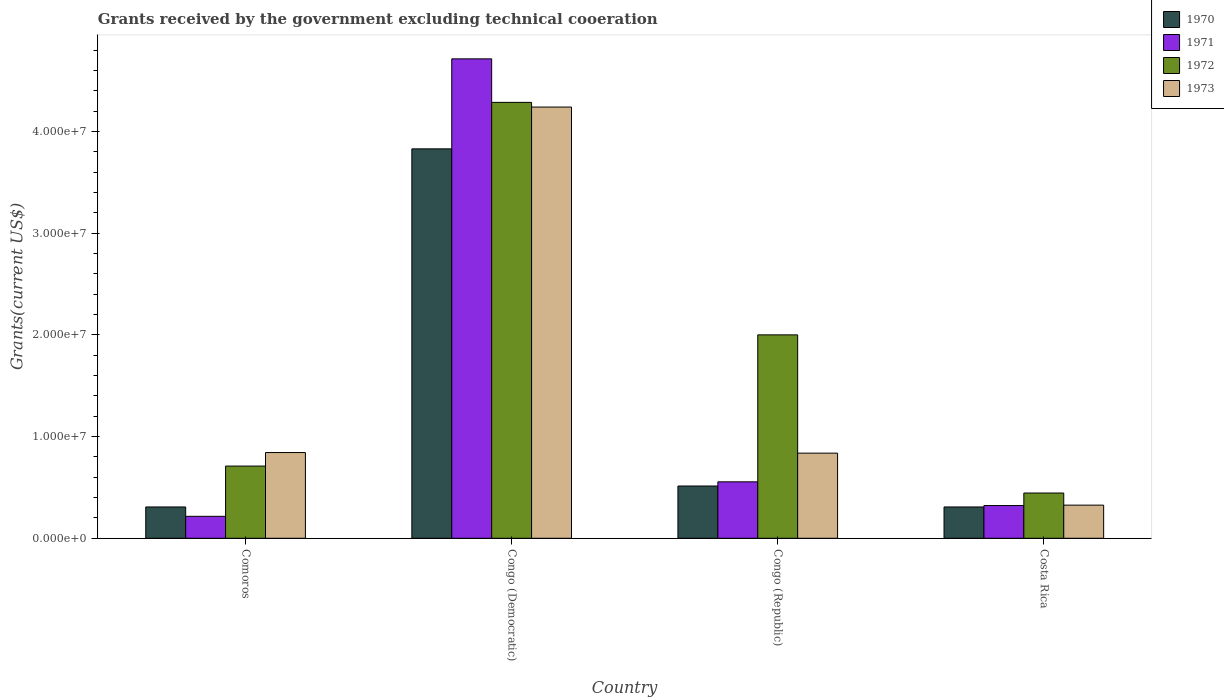Are the number of bars on each tick of the X-axis equal?
Offer a very short reply. Yes. What is the label of the 3rd group of bars from the left?
Provide a succinct answer. Congo (Republic). What is the total grants received by the government in 1973 in Congo (Democratic)?
Your answer should be very brief. 4.24e+07. Across all countries, what is the maximum total grants received by the government in 1971?
Your answer should be compact. 4.71e+07. Across all countries, what is the minimum total grants received by the government in 1973?
Offer a very short reply. 3.26e+06. In which country was the total grants received by the government in 1973 maximum?
Ensure brevity in your answer.  Congo (Democratic). What is the total total grants received by the government in 1972 in the graph?
Give a very brief answer. 7.44e+07. What is the difference between the total grants received by the government in 1972 in Comoros and that in Costa Rica?
Offer a terse response. 2.65e+06. What is the difference between the total grants received by the government in 1971 in Congo (Democratic) and the total grants received by the government in 1970 in Congo (Republic)?
Your answer should be very brief. 4.20e+07. What is the average total grants received by the government in 1970 per country?
Ensure brevity in your answer.  1.24e+07. What is the difference between the total grants received by the government of/in 1972 and total grants received by the government of/in 1970 in Congo (Democratic)?
Your answer should be very brief. 4.57e+06. In how many countries, is the total grants received by the government in 1971 greater than 16000000 US$?
Offer a terse response. 1. What is the ratio of the total grants received by the government in 1972 in Congo (Democratic) to that in Costa Rica?
Provide a short and direct response. 9.63. Is the difference between the total grants received by the government in 1972 in Comoros and Congo (Democratic) greater than the difference between the total grants received by the government in 1970 in Comoros and Congo (Democratic)?
Your response must be concise. No. What is the difference between the highest and the second highest total grants received by the government in 1970?
Give a very brief answer. 3.32e+07. What is the difference between the highest and the lowest total grants received by the government in 1973?
Keep it short and to the point. 3.91e+07. Is the sum of the total grants received by the government in 1970 in Comoros and Congo (Republic) greater than the maximum total grants received by the government in 1972 across all countries?
Make the answer very short. No. Is it the case that in every country, the sum of the total grants received by the government in 1973 and total grants received by the government in 1970 is greater than the sum of total grants received by the government in 1972 and total grants received by the government in 1971?
Offer a terse response. No. Is it the case that in every country, the sum of the total grants received by the government in 1971 and total grants received by the government in 1973 is greater than the total grants received by the government in 1972?
Ensure brevity in your answer.  No. How many bars are there?
Your answer should be very brief. 16. How many countries are there in the graph?
Make the answer very short. 4. Are the values on the major ticks of Y-axis written in scientific E-notation?
Keep it short and to the point. Yes. Does the graph contain any zero values?
Give a very brief answer. No. How many legend labels are there?
Offer a terse response. 4. What is the title of the graph?
Keep it short and to the point. Grants received by the government excluding technical cooeration. Does "1970" appear as one of the legend labels in the graph?
Your answer should be very brief. Yes. What is the label or title of the X-axis?
Ensure brevity in your answer.  Country. What is the label or title of the Y-axis?
Ensure brevity in your answer.  Grants(current US$). What is the Grants(current US$) of 1970 in Comoros?
Offer a terse response. 3.08e+06. What is the Grants(current US$) in 1971 in Comoros?
Your answer should be very brief. 2.16e+06. What is the Grants(current US$) in 1972 in Comoros?
Your answer should be very brief. 7.10e+06. What is the Grants(current US$) of 1973 in Comoros?
Make the answer very short. 8.43e+06. What is the Grants(current US$) of 1970 in Congo (Democratic)?
Provide a succinct answer. 3.83e+07. What is the Grants(current US$) in 1971 in Congo (Democratic)?
Provide a short and direct response. 4.71e+07. What is the Grants(current US$) of 1972 in Congo (Democratic)?
Ensure brevity in your answer.  4.29e+07. What is the Grants(current US$) of 1973 in Congo (Democratic)?
Give a very brief answer. 4.24e+07. What is the Grants(current US$) in 1970 in Congo (Republic)?
Your answer should be very brief. 5.14e+06. What is the Grants(current US$) of 1971 in Congo (Republic)?
Provide a short and direct response. 5.55e+06. What is the Grants(current US$) in 1972 in Congo (Republic)?
Provide a short and direct response. 2.00e+07. What is the Grants(current US$) in 1973 in Congo (Republic)?
Ensure brevity in your answer.  8.37e+06. What is the Grants(current US$) of 1970 in Costa Rica?
Make the answer very short. 3.08e+06. What is the Grants(current US$) in 1971 in Costa Rica?
Offer a terse response. 3.22e+06. What is the Grants(current US$) of 1972 in Costa Rica?
Your response must be concise. 4.45e+06. What is the Grants(current US$) of 1973 in Costa Rica?
Provide a succinct answer. 3.26e+06. Across all countries, what is the maximum Grants(current US$) of 1970?
Provide a succinct answer. 3.83e+07. Across all countries, what is the maximum Grants(current US$) of 1971?
Keep it short and to the point. 4.71e+07. Across all countries, what is the maximum Grants(current US$) in 1972?
Your answer should be compact. 4.29e+07. Across all countries, what is the maximum Grants(current US$) of 1973?
Make the answer very short. 4.24e+07. Across all countries, what is the minimum Grants(current US$) in 1970?
Your answer should be very brief. 3.08e+06. Across all countries, what is the minimum Grants(current US$) in 1971?
Keep it short and to the point. 2.16e+06. Across all countries, what is the minimum Grants(current US$) in 1972?
Your answer should be very brief. 4.45e+06. Across all countries, what is the minimum Grants(current US$) of 1973?
Provide a succinct answer. 3.26e+06. What is the total Grants(current US$) of 1970 in the graph?
Keep it short and to the point. 4.96e+07. What is the total Grants(current US$) of 1971 in the graph?
Keep it short and to the point. 5.81e+07. What is the total Grants(current US$) of 1972 in the graph?
Offer a very short reply. 7.44e+07. What is the total Grants(current US$) in 1973 in the graph?
Provide a succinct answer. 6.25e+07. What is the difference between the Grants(current US$) in 1970 in Comoros and that in Congo (Democratic)?
Make the answer very short. -3.52e+07. What is the difference between the Grants(current US$) in 1971 in Comoros and that in Congo (Democratic)?
Your answer should be very brief. -4.50e+07. What is the difference between the Grants(current US$) of 1972 in Comoros and that in Congo (Democratic)?
Your answer should be very brief. -3.58e+07. What is the difference between the Grants(current US$) of 1973 in Comoros and that in Congo (Democratic)?
Your answer should be very brief. -3.40e+07. What is the difference between the Grants(current US$) in 1970 in Comoros and that in Congo (Republic)?
Provide a short and direct response. -2.06e+06. What is the difference between the Grants(current US$) of 1971 in Comoros and that in Congo (Republic)?
Offer a terse response. -3.39e+06. What is the difference between the Grants(current US$) in 1972 in Comoros and that in Congo (Republic)?
Offer a terse response. -1.29e+07. What is the difference between the Grants(current US$) in 1970 in Comoros and that in Costa Rica?
Ensure brevity in your answer.  0. What is the difference between the Grants(current US$) of 1971 in Comoros and that in Costa Rica?
Provide a short and direct response. -1.06e+06. What is the difference between the Grants(current US$) of 1972 in Comoros and that in Costa Rica?
Offer a terse response. 2.65e+06. What is the difference between the Grants(current US$) in 1973 in Comoros and that in Costa Rica?
Make the answer very short. 5.17e+06. What is the difference between the Grants(current US$) of 1970 in Congo (Democratic) and that in Congo (Republic)?
Provide a short and direct response. 3.32e+07. What is the difference between the Grants(current US$) of 1971 in Congo (Democratic) and that in Congo (Republic)?
Your answer should be compact. 4.16e+07. What is the difference between the Grants(current US$) of 1972 in Congo (Democratic) and that in Congo (Republic)?
Your answer should be very brief. 2.29e+07. What is the difference between the Grants(current US$) of 1973 in Congo (Democratic) and that in Congo (Republic)?
Provide a succinct answer. 3.40e+07. What is the difference between the Grants(current US$) of 1970 in Congo (Democratic) and that in Costa Rica?
Offer a terse response. 3.52e+07. What is the difference between the Grants(current US$) in 1971 in Congo (Democratic) and that in Costa Rica?
Provide a succinct answer. 4.39e+07. What is the difference between the Grants(current US$) in 1972 in Congo (Democratic) and that in Costa Rica?
Your answer should be compact. 3.84e+07. What is the difference between the Grants(current US$) in 1973 in Congo (Democratic) and that in Costa Rica?
Your answer should be very brief. 3.91e+07. What is the difference between the Grants(current US$) of 1970 in Congo (Republic) and that in Costa Rica?
Provide a succinct answer. 2.06e+06. What is the difference between the Grants(current US$) in 1971 in Congo (Republic) and that in Costa Rica?
Offer a terse response. 2.33e+06. What is the difference between the Grants(current US$) in 1972 in Congo (Republic) and that in Costa Rica?
Your response must be concise. 1.56e+07. What is the difference between the Grants(current US$) of 1973 in Congo (Republic) and that in Costa Rica?
Your answer should be very brief. 5.11e+06. What is the difference between the Grants(current US$) in 1970 in Comoros and the Grants(current US$) in 1971 in Congo (Democratic)?
Your response must be concise. -4.41e+07. What is the difference between the Grants(current US$) in 1970 in Comoros and the Grants(current US$) in 1972 in Congo (Democratic)?
Your answer should be very brief. -3.98e+07. What is the difference between the Grants(current US$) in 1970 in Comoros and the Grants(current US$) in 1973 in Congo (Democratic)?
Give a very brief answer. -3.93e+07. What is the difference between the Grants(current US$) of 1971 in Comoros and the Grants(current US$) of 1972 in Congo (Democratic)?
Offer a very short reply. -4.07e+07. What is the difference between the Grants(current US$) of 1971 in Comoros and the Grants(current US$) of 1973 in Congo (Democratic)?
Offer a terse response. -4.02e+07. What is the difference between the Grants(current US$) in 1972 in Comoros and the Grants(current US$) in 1973 in Congo (Democratic)?
Keep it short and to the point. -3.53e+07. What is the difference between the Grants(current US$) of 1970 in Comoros and the Grants(current US$) of 1971 in Congo (Republic)?
Your response must be concise. -2.47e+06. What is the difference between the Grants(current US$) of 1970 in Comoros and the Grants(current US$) of 1972 in Congo (Republic)?
Provide a short and direct response. -1.69e+07. What is the difference between the Grants(current US$) in 1970 in Comoros and the Grants(current US$) in 1973 in Congo (Republic)?
Give a very brief answer. -5.29e+06. What is the difference between the Grants(current US$) of 1971 in Comoros and the Grants(current US$) of 1972 in Congo (Republic)?
Give a very brief answer. -1.78e+07. What is the difference between the Grants(current US$) of 1971 in Comoros and the Grants(current US$) of 1973 in Congo (Republic)?
Make the answer very short. -6.21e+06. What is the difference between the Grants(current US$) in 1972 in Comoros and the Grants(current US$) in 1973 in Congo (Republic)?
Your response must be concise. -1.27e+06. What is the difference between the Grants(current US$) of 1970 in Comoros and the Grants(current US$) of 1972 in Costa Rica?
Offer a terse response. -1.37e+06. What is the difference between the Grants(current US$) of 1970 in Comoros and the Grants(current US$) of 1973 in Costa Rica?
Your answer should be very brief. -1.80e+05. What is the difference between the Grants(current US$) in 1971 in Comoros and the Grants(current US$) in 1972 in Costa Rica?
Your answer should be very brief. -2.29e+06. What is the difference between the Grants(current US$) of 1971 in Comoros and the Grants(current US$) of 1973 in Costa Rica?
Offer a very short reply. -1.10e+06. What is the difference between the Grants(current US$) in 1972 in Comoros and the Grants(current US$) in 1973 in Costa Rica?
Make the answer very short. 3.84e+06. What is the difference between the Grants(current US$) of 1970 in Congo (Democratic) and the Grants(current US$) of 1971 in Congo (Republic)?
Your response must be concise. 3.27e+07. What is the difference between the Grants(current US$) in 1970 in Congo (Democratic) and the Grants(current US$) in 1972 in Congo (Republic)?
Provide a short and direct response. 1.83e+07. What is the difference between the Grants(current US$) of 1970 in Congo (Democratic) and the Grants(current US$) of 1973 in Congo (Republic)?
Make the answer very short. 2.99e+07. What is the difference between the Grants(current US$) of 1971 in Congo (Democratic) and the Grants(current US$) of 1972 in Congo (Republic)?
Ensure brevity in your answer.  2.71e+07. What is the difference between the Grants(current US$) in 1971 in Congo (Democratic) and the Grants(current US$) in 1973 in Congo (Republic)?
Offer a terse response. 3.88e+07. What is the difference between the Grants(current US$) in 1972 in Congo (Democratic) and the Grants(current US$) in 1973 in Congo (Republic)?
Your answer should be very brief. 3.45e+07. What is the difference between the Grants(current US$) in 1970 in Congo (Democratic) and the Grants(current US$) in 1971 in Costa Rica?
Offer a very short reply. 3.51e+07. What is the difference between the Grants(current US$) in 1970 in Congo (Democratic) and the Grants(current US$) in 1972 in Costa Rica?
Provide a short and direct response. 3.38e+07. What is the difference between the Grants(current US$) in 1970 in Congo (Democratic) and the Grants(current US$) in 1973 in Costa Rica?
Offer a terse response. 3.50e+07. What is the difference between the Grants(current US$) in 1971 in Congo (Democratic) and the Grants(current US$) in 1972 in Costa Rica?
Your response must be concise. 4.27e+07. What is the difference between the Grants(current US$) of 1971 in Congo (Democratic) and the Grants(current US$) of 1973 in Costa Rica?
Offer a terse response. 4.39e+07. What is the difference between the Grants(current US$) of 1972 in Congo (Democratic) and the Grants(current US$) of 1973 in Costa Rica?
Your answer should be very brief. 3.96e+07. What is the difference between the Grants(current US$) in 1970 in Congo (Republic) and the Grants(current US$) in 1971 in Costa Rica?
Keep it short and to the point. 1.92e+06. What is the difference between the Grants(current US$) in 1970 in Congo (Republic) and the Grants(current US$) in 1972 in Costa Rica?
Offer a very short reply. 6.90e+05. What is the difference between the Grants(current US$) in 1970 in Congo (Republic) and the Grants(current US$) in 1973 in Costa Rica?
Offer a very short reply. 1.88e+06. What is the difference between the Grants(current US$) of 1971 in Congo (Republic) and the Grants(current US$) of 1972 in Costa Rica?
Offer a terse response. 1.10e+06. What is the difference between the Grants(current US$) of 1971 in Congo (Republic) and the Grants(current US$) of 1973 in Costa Rica?
Make the answer very short. 2.29e+06. What is the difference between the Grants(current US$) of 1972 in Congo (Republic) and the Grants(current US$) of 1973 in Costa Rica?
Give a very brief answer. 1.67e+07. What is the average Grants(current US$) of 1970 per country?
Offer a very short reply. 1.24e+07. What is the average Grants(current US$) of 1971 per country?
Your answer should be very brief. 1.45e+07. What is the average Grants(current US$) in 1972 per country?
Your answer should be compact. 1.86e+07. What is the average Grants(current US$) in 1973 per country?
Your answer should be compact. 1.56e+07. What is the difference between the Grants(current US$) in 1970 and Grants(current US$) in 1971 in Comoros?
Provide a short and direct response. 9.20e+05. What is the difference between the Grants(current US$) of 1970 and Grants(current US$) of 1972 in Comoros?
Provide a succinct answer. -4.02e+06. What is the difference between the Grants(current US$) of 1970 and Grants(current US$) of 1973 in Comoros?
Make the answer very short. -5.35e+06. What is the difference between the Grants(current US$) of 1971 and Grants(current US$) of 1972 in Comoros?
Your response must be concise. -4.94e+06. What is the difference between the Grants(current US$) in 1971 and Grants(current US$) in 1973 in Comoros?
Provide a short and direct response. -6.27e+06. What is the difference between the Grants(current US$) of 1972 and Grants(current US$) of 1973 in Comoros?
Provide a succinct answer. -1.33e+06. What is the difference between the Grants(current US$) in 1970 and Grants(current US$) in 1971 in Congo (Democratic)?
Make the answer very short. -8.85e+06. What is the difference between the Grants(current US$) in 1970 and Grants(current US$) in 1972 in Congo (Democratic)?
Your answer should be very brief. -4.57e+06. What is the difference between the Grants(current US$) of 1970 and Grants(current US$) of 1973 in Congo (Democratic)?
Your response must be concise. -4.11e+06. What is the difference between the Grants(current US$) in 1971 and Grants(current US$) in 1972 in Congo (Democratic)?
Your answer should be compact. 4.28e+06. What is the difference between the Grants(current US$) of 1971 and Grants(current US$) of 1973 in Congo (Democratic)?
Your answer should be compact. 4.74e+06. What is the difference between the Grants(current US$) in 1970 and Grants(current US$) in 1971 in Congo (Republic)?
Keep it short and to the point. -4.10e+05. What is the difference between the Grants(current US$) of 1970 and Grants(current US$) of 1972 in Congo (Republic)?
Offer a very short reply. -1.49e+07. What is the difference between the Grants(current US$) in 1970 and Grants(current US$) in 1973 in Congo (Republic)?
Your response must be concise. -3.23e+06. What is the difference between the Grants(current US$) of 1971 and Grants(current US$) of 1972 in Congo (Republic)?
Keep it short and to the point. -1.44e+07. What is the difference between the Grants(current US$) of 1971 and Grants(current US$) of 1973 in Congo (Republic)?
Make the answer very short. -2.82e+06. What is the difference between the Grants(current US$) in 1972 and Grants(current US$) in 1973 in Congo (Republic)?
Your answer should be very brief. 1.16e+07. What is the difference between the Grants(current US$) of 1970 and Grants(current US$) of 1972 in Costa Rica?
Provide a short and direct response. -1.37e+06. What is the difference between the Grants(current US$) in 1971 and Grants(current US$) in 1972 in Costa Rica?
Your response must be concise. -1.23e+06. What is the difference between the Grants(current US$) of 1971 and Grants(current US$) of 1973 in Costa Rica?
Your answer should be compact. -4.00e+04. What is the difference between the Grants(current US$) in 1972 and Grants(current US$) in 1973 in Costa Rica?
Provide a short and direct response. 1.19e+06. What is the ratio of the Grants(current US$) in 1970 in Comoros to that in Congo (Democratic)?
Give a very brief answer. 0.08. What is the ratio of the Grants(current US$) in 1971 in Comoros to that in Congo (Democratic)?
Ensure brevity in your answer.  0.05. What is the ratio of the Grants(current US$) of 1972 in Comoros to that in Congo (Democratic)?
Your response must be concise. 0.17. What is the ratio of the Grants(current US$) of 1973 in Comoros to that in Congo (Democratic)?
Your response must be concise. 0.2. What is the ratio of the Grants(current US$) of 1970 in Comoros to that in Congo (Republic)?
Provide a succinct answer. 0.6. What is the ratio of the Grants(current US$) in 1971 in Comoros to that in Congo (Republic)?
Offer a terse response. 0.39. What is the ratio of the Grants(current US$) of 1972 in Comoros to that in Congo (Republic)?
Offer a terse response. 0.35. What is the ratio of the Grants(current US$) in 1973 in Comoros to that in Congo (Republic)?
Your response must be concise. 1.01. What is the ratio of the Grants(current US$) of 1970 in Comoros to that in Costa Rica?
Your answer should be compact. 1. What is the ratio of the Grants(current US$) in 1971 in Comoros to that in Costa Rica?
Your response must be concise. 0.67. What is the ratio of the Grants(current US$) of 1972 in Comoros to that in Costa Rica?
Give a very brief answer. 1.6. What is the ratio of the Grants(current US$) in 1973 in Comoros to that in Costa Rica?
Provide a succinct answer. 2.59. What is the ratio of the Grants(current US$) of 1970 in Congo (Democratic) to that in Congo (Republic)?
Your answer should be very brief. 7.45. What is the ratio of the Grants(current US$) in 1971 in Congo (Democratic) to that in Congo (Republic)?
Provide a short and direct response. 8.49. What is the ratio of the Grants(current US$) of 1972 in Congo (Democratic) to that in Congo (Republic)?
Keep it short and to the point. 2.14. What is the ratio of the Grants(current US$) in 1973 in Congo (Democratic) to that in Congo (Republic)?
Provide a short and direct response. 5.07. What is the ratio of the Grants(current US$) of 1970 in Congo (Democratic) to that in Costa Rica?
Provide a short and direct response. 12.43. What is the ratio of the Grants(current US$) of 1971 in Congo (Democratic) to that in Costa Rica?
Give a very brief answer. 14.64. What is the ratio of the Grants(current US$) of 1972 in Congo (Democratic) to that in Costa Rica?
Keep it short and to the point. 9.63. What is the ratio of the Grants(current US$) of 1973 in Congo (Democratic) to that in Costa Rica?
Your response must be concise. 13.01. What is the ratio of the Grants(current US$) of 1970 in Congo (Republic) to that in Costa Rica?
Provide a short and direct response. 1.67. What is the ratio of the Grants(current US$) in 1971 in Congo (Republic) to that in Costa Rica?
Provide a succinct answer. 1.72. What is the ratio of the Grants(current US$) of 1972 in Congo (Republic) to that in Costa Rica?
Offer a terse response. 4.49. What is the ratio of the Grants(current US$) in 1973 in Congo (Republic) to that in Costa Rica?
Provide a succinct answer. 2.57. What is the difference between the highest and the second highest Grants(current US$) of 1970?
Your answer should be very brief. 3.32e+07. What is the difference between the highest and the second highest Grants(current US$) in 1971?
Keep it short and to the point. 4.16e+07. What is the difference between the highest and the second highest Grants(current US$) in 1972?
Offer a terse response. 2.29e+07. What is the difference between the highest and the second highest Grants(current US$) in 1973?
Your answer should be very brief. 3.40e+07. What is the difference between the highest and the lowest Grants(current US$) of 1970?
Your answer should be compact. 3.52e+07. What is the difference between the highest and the lowest Grants(current US$) in 1971?
Your answer should be very brief. 4.50e+07. What is the difference between the highest and the lowest Grants(current US$) in 1972?
Provide a succinct answer. 3.84e+07. What is the difference between the highest and the lowest Grants(current US$) in 1973?
Your response must be concise. 3.91e+07. 